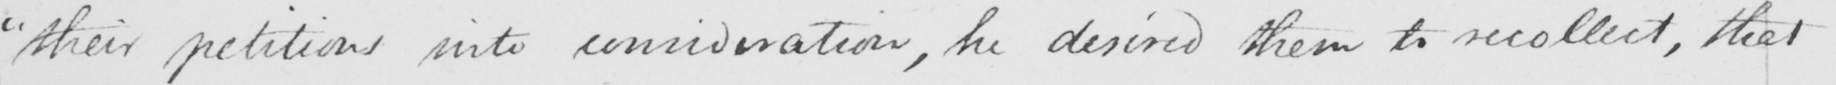What does this handwritten line say? " their petitions into consideration , he desired them to recollect , that 